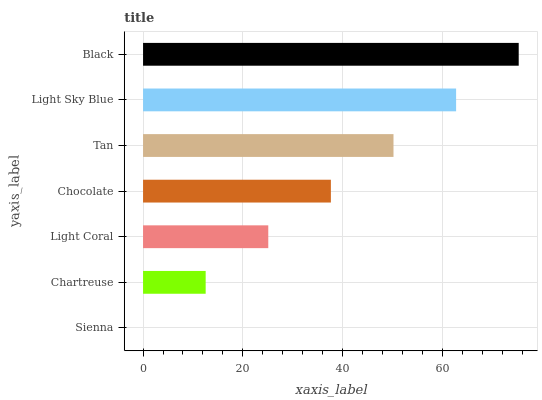Is Sienna the minimum?
Answer yes or no. Yes. Is Black the maximum?
Answer yes or no. Yes. Is Chartreuse the minimum?
Answer yes or no. No. Is Chartreuse the maximum?
Answer yes or no. No. Is Chartreuse greater than Sienna?
Answer yes or no. Yes. Is Sienna less than Chartreuse?
Answer yes or no. Yes. Is Sienna greater than Chartreuse?
Answer yes or no. No. Is Chartreuse less than Sienna?
Answer yes or no. No. Is Chocolate the high median?
Answer yes or no. Yes. Is Chocolate the low median?
Answer yes or no. Yes. Is Tan the high median?
Answer yes or no. No. Is Light Sky Blue the low median?
Answer yes or no. No. 